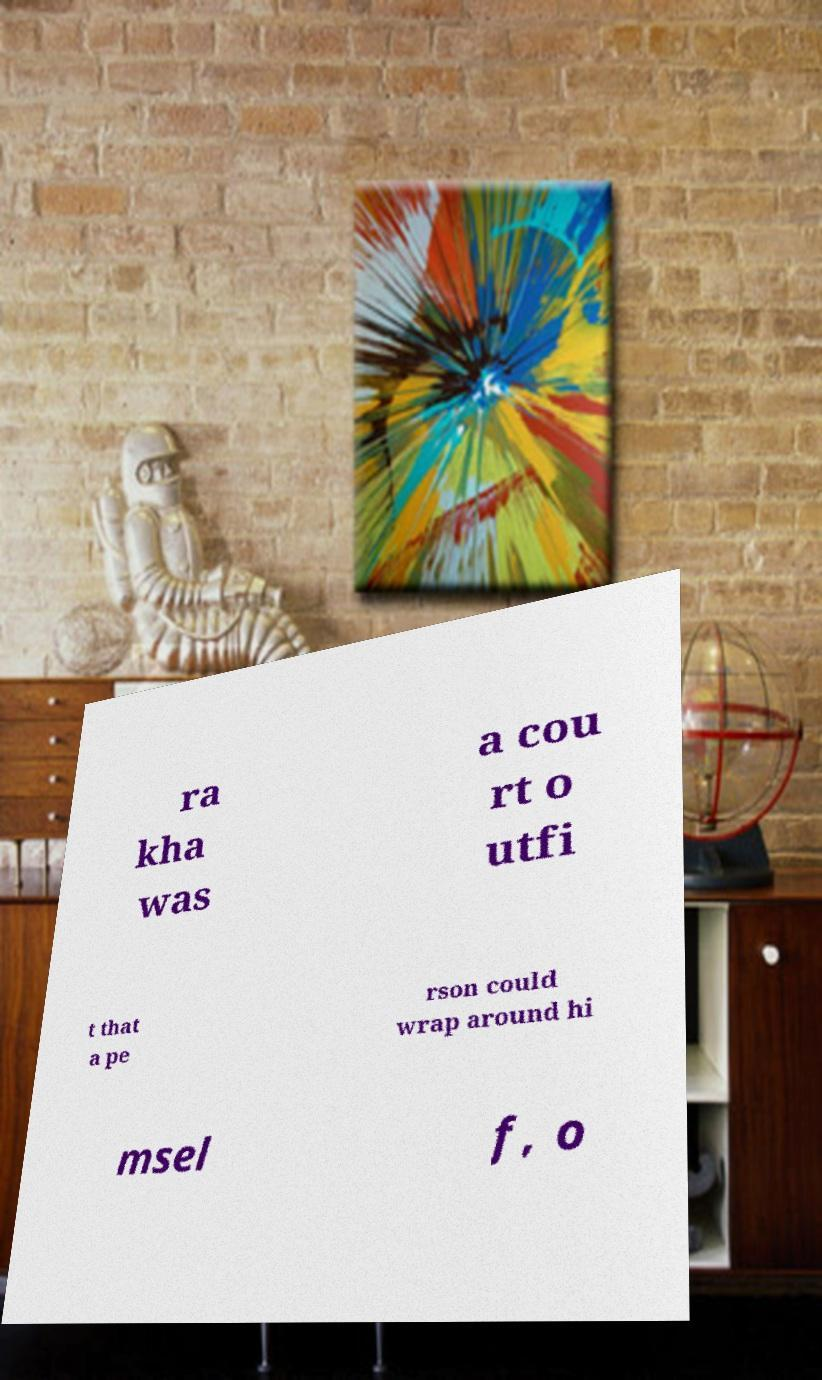Please read and relay the text visible in this image. What does it say? ra kha was a cou rt o utfi t that a pe rson could wrap around hi msel f, o 